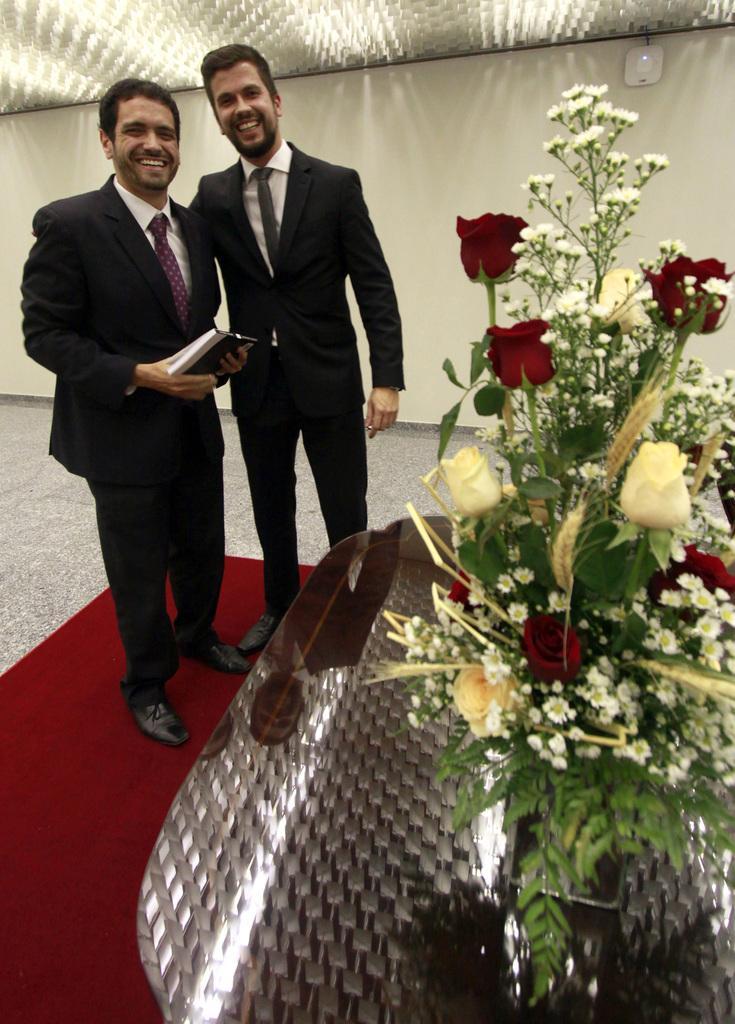Could you give a brief overview of what you see in this image? In this image we can see two persons standing on the red carpet. A person in that is holding a box. On the right side we can see a flower pot on the table. On the backside we can see a wall, floor and a roof. 